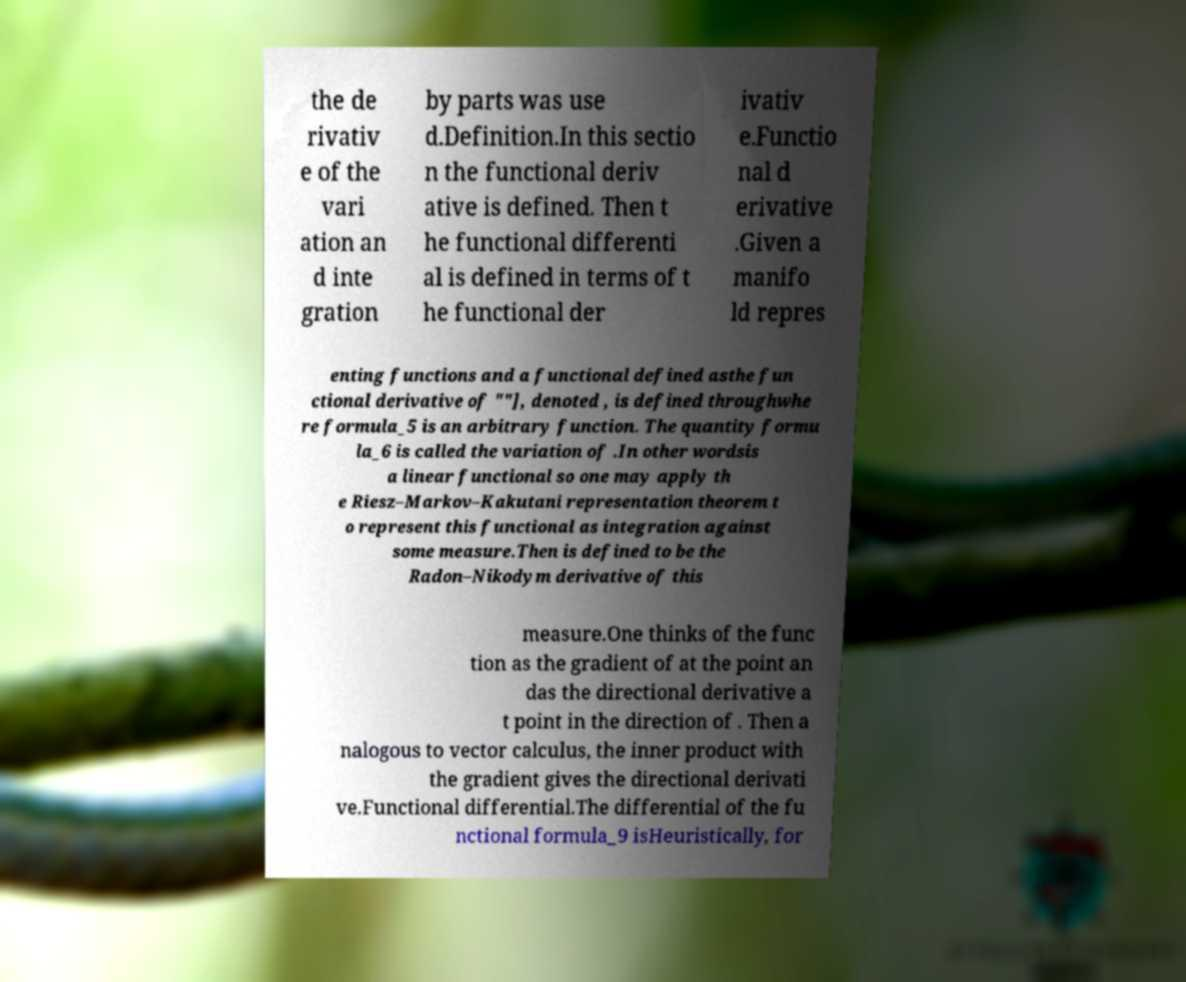Please read and relay the text visible in this image. What does it say? the de rivativ e of the vari ation an d inte gration by parts was use d.Definition.In this sectio n the functional deriv ative is defined. Then t he functional differenti al is defined in terms of t he functional der ivativ e.Functio nal d erivative .Given a manifo ld repres enting functions and a functional defined asthe fun ctional derivative of ""], denoted , is defined throughwhe re formula_5 is an arbitrary function. The quantity formu la_6 is called the variation of .In other wordsis a linear functional so one may apply th e Riesz–Markov–Kakutani representation theorem t o represent this functional as integration against some measure.Then is defined to be the Radon–Nikodym derivative of this measure.One thinks of the func tion as the gradient of at the point an das the directional derivative a t point in the direction of . Then a nalogous to vector calculus, the inner product with the gradient gives the directional derivati ve.Functional differential.The differential of the fu nctional formula_9 isHeuristically, for 